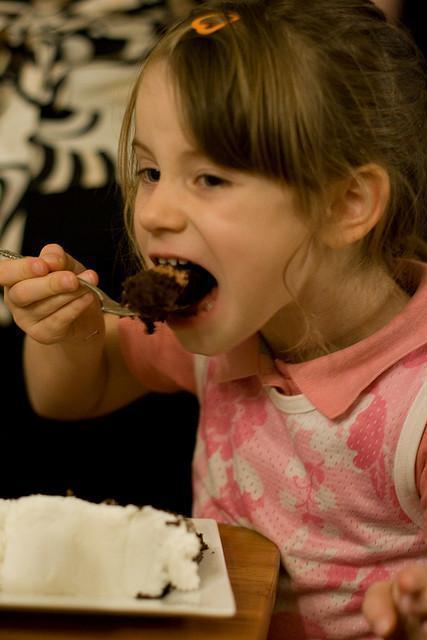How many horses are there in the photo?
Give a very brief answer. 0. 